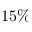Convert formula to latex. <formula><loc_0><loc_0><loc_500><loc_500>1 5 \%</formula> 